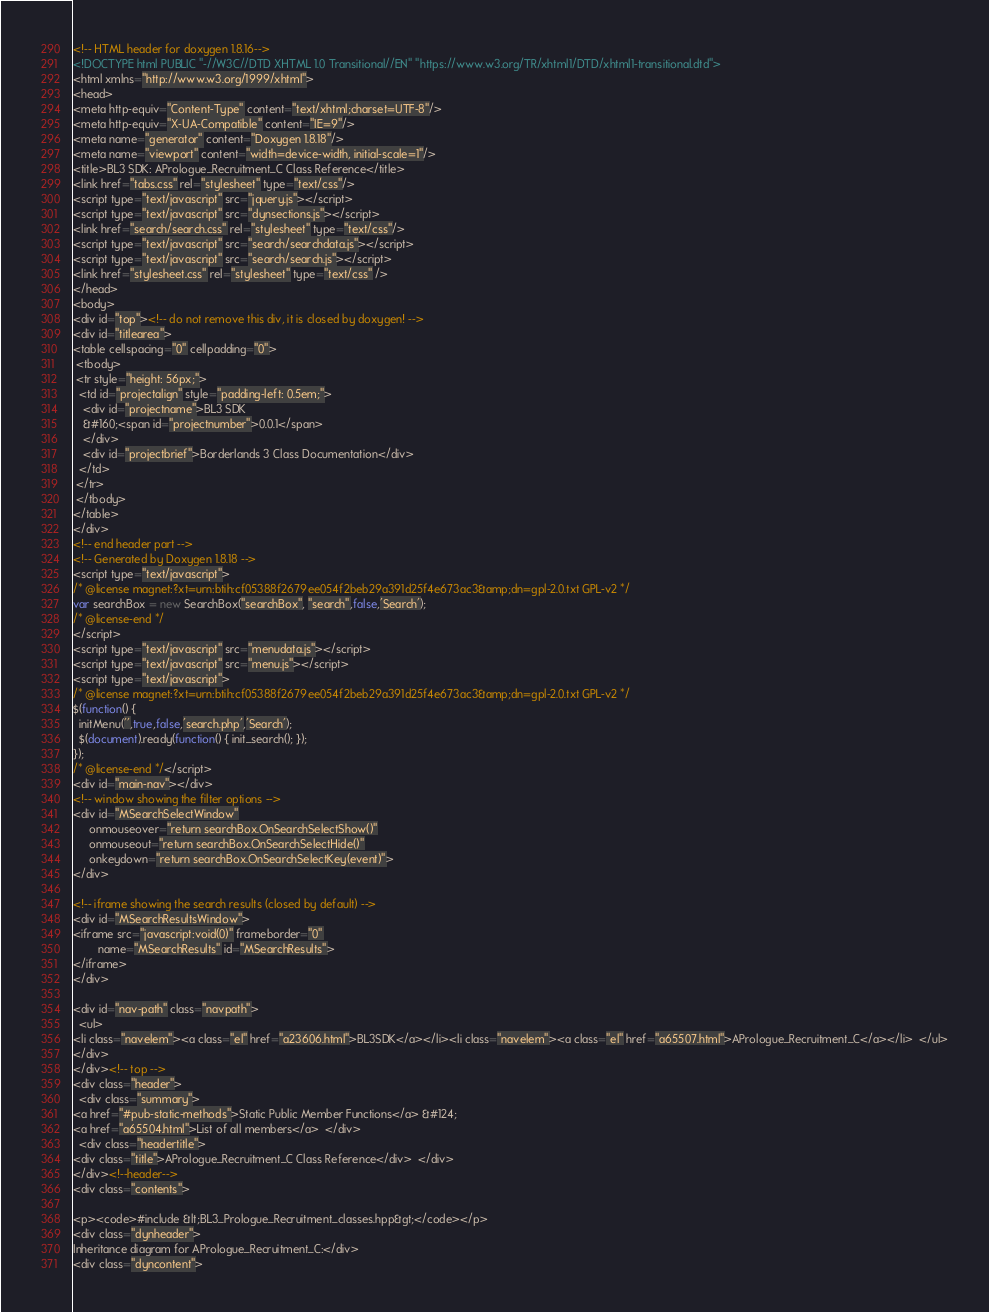Convert code to text. <code><loc_0><loc_0><loc_500><loc_500><_HTML_><!-- HTML header for doxygen 1.8.16-->
<!DOCTYPE html PUBLIC "-//W3C//DTD XHTML 1.0 Transitional//EN" "https://www.w3.org/TR/xhtml1/DTD/xhtml1-transitional.dtd">
<html xmlns="http://www.w3.org/1999/xhtml">
<head>
<meta http-equiv="Content-Type" content="text/xhtml;charset=UTF-8"/>
<meta http-equiv="X-UA-Compatible" content="IE=9"/>
<meta name="generator" content="Doxygen 1.8.18"/>
<meta name="viewport" content="width=device-width, initial-scale=1"/>
<title>BL3 SDK: APrologue_Recruitment_C Class Reference</title>
<link href="tabs.css" rel="stylesheet" type="text/css"/>
<script type="text/javascript" src="jquery.js"></script>
<script type="text/javascript" src="dynsections.js"></script>
<link href="search/search.css" rel="stylesheet" type="text/css"/>
<script type="text/javascript" src="search/searchdata.js"></script>
<script type="text/javascript" src="search/search.js"></script>
<link href="stylesheet.css" rel="stylesheet" type="text/css" />
</head>
<body>
<div id="top"><!-- do not remove this div, it is closed by doxygen! -->
<div id="titlearea">
<table cellspacing="0" cellpadding="0">
 <tbody>
 <tr style="height: 56px;">
  <td id="projectalign" style="padding-left: 0.5em;">
   <div id="projectname">BL3 SDK
   &#160;<span id="projectnumber">0.0.1</span>
   </div>
   <div id="projectbrief">Borderlands 3 Class Documentation</div>
  </td>
 </tr>
 </tbody>
</table>
</div>
<!-- end header part -->
<!-- Generated by Doxygen 1.8.18 -->
<script type="text/javascript">
/* @license magnet:?xt=urn:btih:cf05388f2679ee054f2beb29a391d25f4e673ac3&amp;dn=gpl-2.0.txt GPL-v2 */
var searchBox = new SearchBox("searchBox", "search",false,'Search');
/* @license-end */
</script>
<script type="text/javascript" src="menudata.js"></script>
<script type="text/javascript" src="menu.js"></script>
<script type="text/javascript">
/* @license magnet:?xt=urn:btih:cf05388f2679ee054f2beb29a391d25f4e673ac3&amp;dn=gpl-2.0.txt GPL-v2 */
$(function() {
  initMenu('',true,false,'search.php','Search');
  $(document).ready(function() { init_search(); });
});
/* @license-end */</script>
<div id="main-nav"></div>
<!-- window showing the filter options -->
<div id="MSearchSelectWindow"
     onmouseover="return searchBox.OnSearchSelectShow()"
     onmouseout="return searchBox.OnSearchSelectHide()"
     onkeydown="return searchBox.OnSearchSelectKey(event)">
</div>

<!-- iframe showing the search results (closed by default) -->
<div id="MSearchResultsWindow">
<iframe src="javascript:void(0)" frameborder="0" 
        name="MSearchResults" id="MSearchResults">
</iframe>
</div>

<div id="nav-path" class="navpath">
  <ul>
<li class="navelem"><a class="el" href="a23606.html">BL3SDK</a></li><li class="navelem"><a class="el" href="a65507.html">APrologue_Recruitment_C</a></li>  </ul>
</div>
</div><!-- top -->
<div class="header">
  <div class="summary">
<a href="#pub-static-methods">Static Public Member Functions</a> &#124;
<a href="a65504.html">List of all members</a>  </div>
  <div class="headertitle">
<div class="title">APrologue_Recruitment_C Class Reference</div>  </div>
</div><!--header-->
<div class="contents">

<p><code>#include &lt;BL3_Prologue_Recruitment_classes.hpp&gt;</code></p>
<div class="dynheader">
Inheritance diagram for APrologue_Recruitment_C:</div>
<div class="dyncontent"></code> 